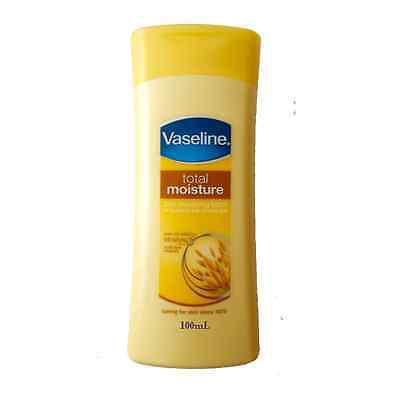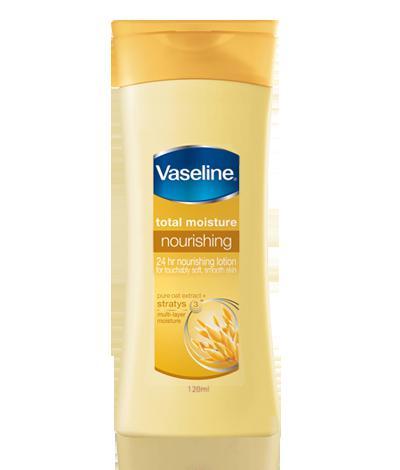The first image is the image on the left, the second image is the image on the right. Given the left and right images, does the statement "There are two yellow bottles of lotion" hold true? Answer yes or no. Yes. 